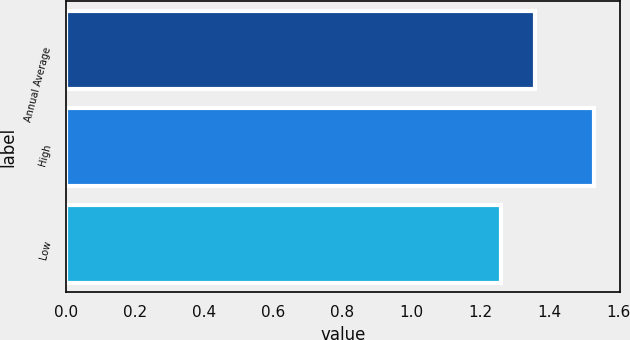Convert chart to OTSL. <chart><loc_0><loc_0><loc_500><loc_500><bar_chart><fcel>Annual Average<fcel>High<fcel>Low<nl><fcel>1.36<fcel>1.53<fcel>1.26<nl></chart> 